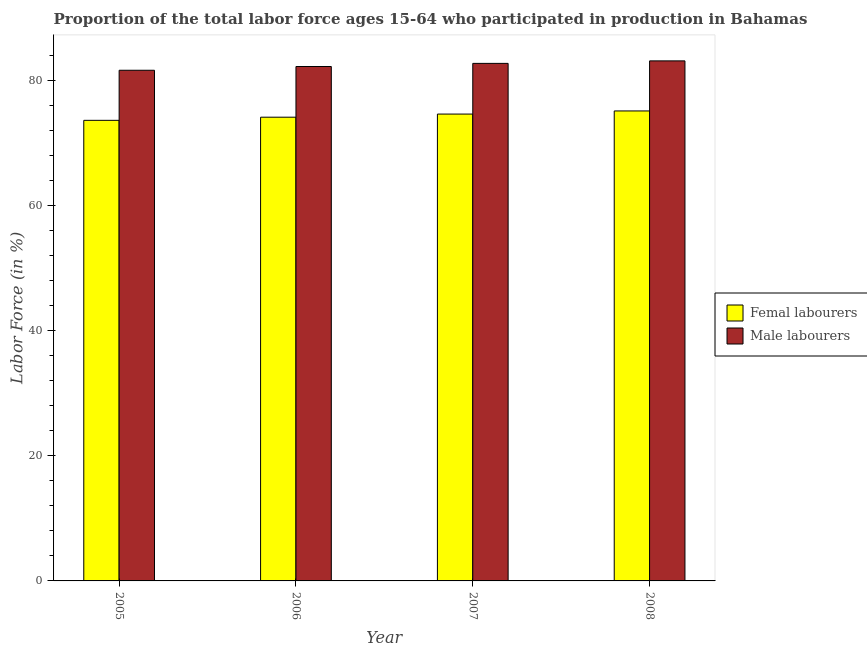How many different coloured bars are there?
Your answer should be compact. 2. How many groups of bars are there?
Your answer should be compact. 4. How many bars are there on the 3rd tick from the right?
Offer a terse response. 2. What is the label of the 3rd group of bars from the left?
Provide a succinct answer. 2007. What is the percentage of male labour force in 2008?
Offer a very short reply. 83.1. Across all years, what is the maximum percentage of male labour force?
Ensure brevity in your answer.  83.1. Across all years, what is the minimum percentage of male labour force?
Your response must be concise. 81.6. In which year was the percentage of male labour force maximum?
Provide a succinct answer. 2008. In which year was the percentage of female labor force minimum?
Offer a very short reply. 2005. What is the total percentage of female labor force in the graph?
Ensure brevity in your answer.  297.4. What is the average percentage of male labour force per year?
Offer a very short reply. 82.4. What is the ratio of the percentage of female labor force in 2005 to that in 2007?
Provide a succinct answer. 0.99. Is the difference between the percentage of male labour force in 2006 and 2007 greater than the difference between the percentage of female labor force in 2006 and 2007?
Make the answer very short. No. What is the difference between the highest and the lowest percentage of male labour force?
Your answer should be very brief. 1.5. In how many years, is the percentage of male labour force greater than the average percentage of male labour force taken over all years?
Make the answer very short. 2. What does the 1st bar from the left in 2008 represents?
Give a very brief answer. Femal labourers. What does the 2nd bar from the right in 2007 represents?
Your response must be concise. Femal labourers. How many bars are there?
Your answer should be very brief. 8. How many years are there in the graph?
Make the answer very short. 4. Are the values on the major ticks of Y-axis written in scientific E-notation?
Your answer should be compact. No. Does the graph contain any zero values?
Provide a short and direct response. No. Does the graph contain grids?
Give a very brief answer. No. How many legend labels are there?
Provide a succinct answer. 2. What is the title of the graph?
Offer a terse response. Proportion of the total labor force ages 15-64 who participated in production in Bahamas. What is the Labor Force (in %) of Femal labourers in 2005?
Give a very brief answer. 73.6. What is the Labor Force (in %) in Male labourers in 2005?
Ensure brevity in your answer.  81.6. What is the Labor Force (in %) of Femal labourers in 2006?
Keep it short and to the point. 74.1. What is the Labor Force (in %) in Male labourers in 2006?
Offer a very short reply. 82.2. What is the Labor Force (in %) of Femal labourers in 2007?
Provide a short and direct response. 74.6. What is the Labor Force (in %) in Male labourers in 2007?
Make the answer very short. 82.7. What is the Labor Force (in %) of Femal labourers in 2008?
Your answer should be compact. 75.1. What is the Labor Force (in %) of Male labourers in 2008?
Offer a terse response. 83.1. Across all years, what is the maximum Labor Force (in %) of Femal labourers?
Provide a short and direct response. 75.1. Across all years, what is the maximum Labor Force (in %) of Male labourers?
Provide a short and direct response. 83.1. Across all years, what is the minimum Labor Force (in %) of Femal labourers?
Your answer should be very brief. 73.6. Across all years, what is the minimum Labor Force (in %) in Male labourers?
Give a very brief answer. 81.6. What is the total Labor Force (in %) of Femal labourers in the graph?
Your response must be concise. 297.4. What is the total Labor Force (in %) in Male labourers in the graph?
Keep it short and to the point. 329.6. What is the difference between the Labor Force (in %) in Femal labourers in 2005 and that in 2006?
Ensure brevity in your answer.  -0.5. What is the difference between the Labor Force (in %) in Male labourers in 2005 and that in 2006?
Offer a very short reply. -0.6. What is the difference between the Labor Force (in %) in Femal labourers in 2005 and that in 2008?
Offer a very short reply. -1.5. What is the difference between the Labor Force (in %) in Femal labourers in 2006 and that in 2007?
Give a very brief answer. -0.5. What is the difference between the Labor Force (in %) in Femal labourers in 2006 and that in 2008?
Provide a short and direct response. -1. What is the difference between the Labor Force (in %) in Male labourers in 2006 and that in 2008?
Offer a very short reply. -0.9. What is the difference between the Labor Force (in %) of Male labourers in 2007 and that in 2008?
Your answer should be compact. -0.4. What is the difference between the Labor Force (in %) in Femal labourers in 2005 and the Labor Force (in %) in Male labourers in 2006?
Make the answer very short. -8.6. What is the difference between the Labor Force (in %) in Femal labourers in 2005 and the Labor Force (in %) in Male labourers in 2007?
Offer a very short reply. -9.1. What is the difference between the Labor Force (in %) of Femal labourers in 2006 and the Labor Force (in %) of Male labourers in 2007?
Give a very brief answer. -8.6. What is the difference between the Labor Force (in %) of Femal labourers in 2006 and the Labor Force (in %) of Male labourers in 2008?
Make the answer very short. -9. What is the difference between the Labor Force (in %) in Femal labourers in 2007 and the Labor Force (in %) in Male labourers in 2008?
Make the answer very short. -8.5. What is the average Labor Force (in %) of Femal labourers per year?
Offer a terse response. 74.35. What is the average Labor Force (in %) of Male labourers per year?
Give a very brief answer. 82.4. In the year 2005, what is the difference between the Labor Force (in %) of Femal labourers and Labor Force (in %) of Male labourers?
Give a very brief answer. -8. What is the ratio of the Labor Force (in %) in Femal labourers in 2005 to that in 2007?
Your response must be concise. 0.99. What is the ratio of the Labor Force (in %) of Male labourers in 2005 to that in 2007?
Provide a short and direct response. 0.99. What is the ratio of the Labor Force (in %) in Male labourers in 2005 to that in 2008?
Your answer should be compact. 0.98. What is the ratio of the Labor Force (in %) of Femal labourers in 2006 to that in 2007?
Give a very brief answer. 0.99. What is the ratio of the Labor Force (in %) of Male labourers in 2006 to that in 2007?
Your answer should be very brief. 0.99. What is the ratio of the Labor Force (in %) of Femal labourers in 2006 to that in 2008?
Give a very brief answer. 0.99. What is the ratio of the Labor Force (in %) of Male labourers in 2006 to that in 2008?
Offer a very short reply. 0.99. What is the ratio of the Labor Force (in %) in Male labourers in 2007 to that in 2008?
Your answer should be very brief. 1. What is the difference between the highest and the second highest Labor Force (in %) in Femal labourers?
Your answer should be compact. 0.5. What is the difference between the highest and the lowest Labor Force (in %) of Femal labourers?
Provide a short and direct response. 1.5. What is the difference between the highest and the lowest Labor Force (in %) in Male labourers?
Provide a succinct answer. 1.5. 